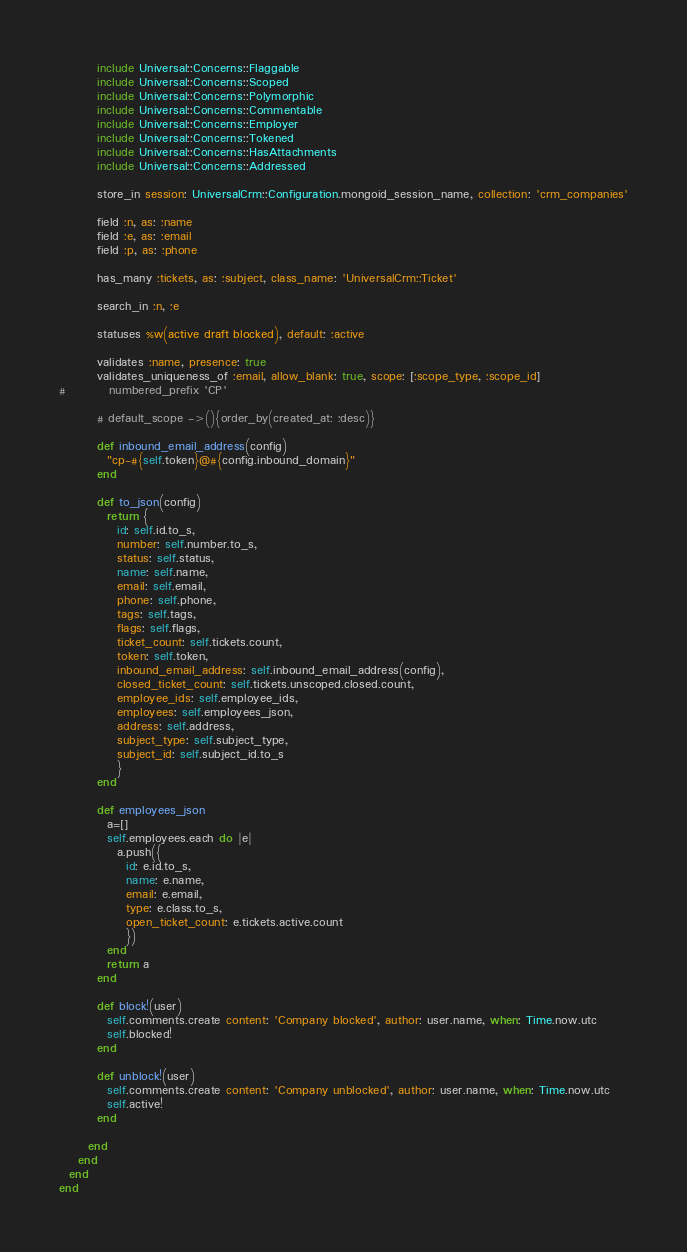<code> <loc_0><loc_0><loc_500><loc_500><_Ruby_>        include Universal::Concerns::Flaggable
        include Universal::Concerns::Scoped
        include Universal::Concerns::Polymorphic
        include Universal::Concerns::Commentable
        include Universal::Concerns::Employer
        include Universal::Concerns::Tokened
        include Universal::Concerns::HasAttachments
        include Universal::Concerns::Addressed
        
        store_in session: UniversalCrm::Configuration.mongoid_session_name, collection: 'crm_companies'

        field :n, as: :name
        field :e, as: :email
        field :p, as: :phone
        
        has_many :tickets, as: :subject, class_name: 'UniversalCrm::Ticket'
        
        search_in :n, :e

        statuses %w(active draft blocked), default: :active
        
        validates :name, presence: true
        validates_uniqueness_of :email, allow_blank: true, scope: [:scope_type, :scope_id]
#         numbered_prefix 'CP'
        
        # default_scope ->(){order_by(created_at: :desc)}
        
        def inbound_email_address(config)
          "cp-#{self.token}@#{config.inbound_domain}"
        end
        
        def to_json(config)
          return {
            id: self.id.to_s,
            number: self.number.to_s,
            status: self.status,
            name: self.name,
            email: self.email, 
            phone: self.phone,
            tags: self.tags,
            flags: self.flags,
            ticket_count: self.tickets.count, 
            token: self.token,
            inbound_email_address: self.inbound_email_address(config),
            closed_ticket_count: self.tickets.unscoped.closed.count,
            employee_ids: self.employee_ids,
            employees: self.employees_json,
            address: self.address,
            subject_type: self.subject_type,
            subject_id: self.subject_id.to_s
            }
        end
        
        def employees_json
          a=[]
          self.employees.each do |e|
            a.push({
              id: e.id.to_s,
              name: e.name,
              email: e.email,
              type: e.class.to_s,
              open_ticket_count: e.tickets.active.count
              })
          end
          return a
        end
        
        def block!(user)
          self.comments.create content: 'Company blocked', author: user.name, when: Time.now.utc
          self.blocked!
        end
        
        def unblock!(user)
          self.comments.create content: 'Company unblocked', author: user.name, when: Time.now.utc
          self.active!
        end
        
      end
    end
  end
end</code> 